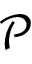Convert formula to latex. <formula><loc_0><loc_0><loc_500><loc_500>\mathcal { P }</formula> 